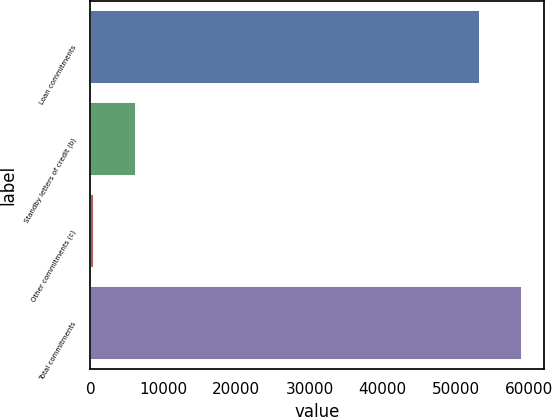Convert chart. <chart><loc_0><loc_0><loc_500><loc_500><bar_chart><fcel>Loan commitments<fcel>Standby letters of credit (b)<fcel>Other commitments (c)<fcel>Total commitments<nl><fcel>53347<fcel>6283.8<fcel>473<fcel>59157.8<nl></chart> 